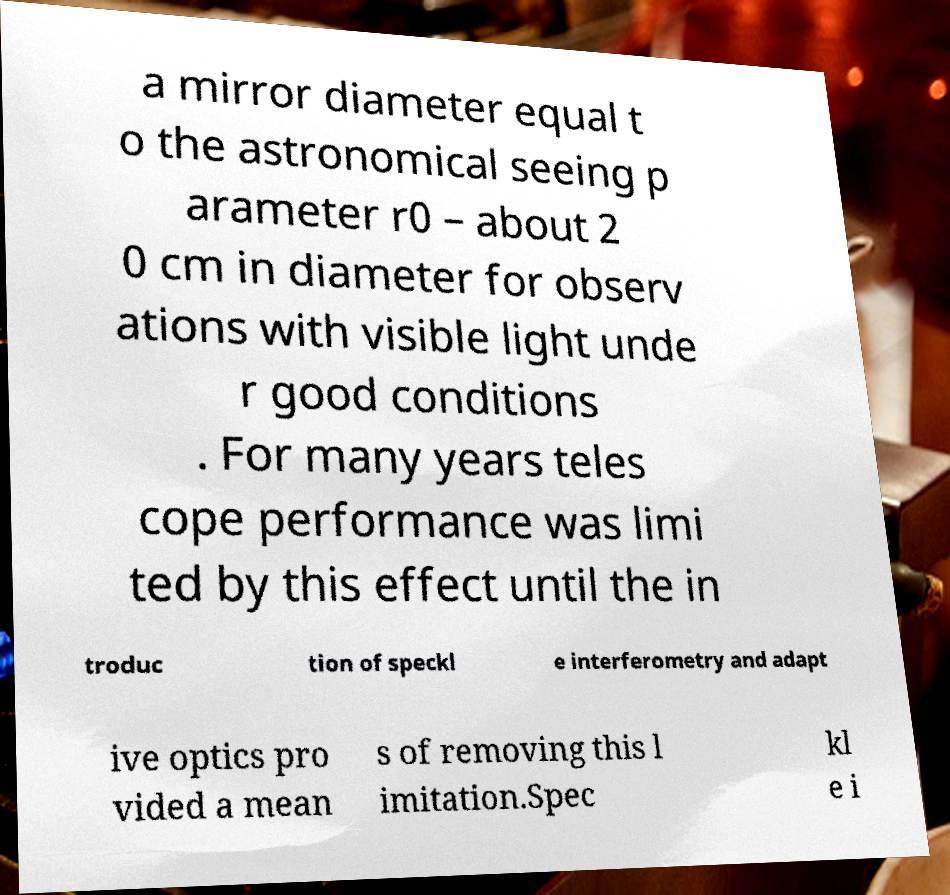What messages or text are displayed in this image? I need them in a readable, typed format. a mirror diameter equal t o the astronomical seeing p arameter r0 – about 2 0 cm in diameter for observ ations with visible light unde r good conditions . For many years teles cope performance was limi ted by this effect until the in troduc tion of speckl e interferometry and adapt ive optics pro vided a mean s of removing this l imitation.Spec kl e i 